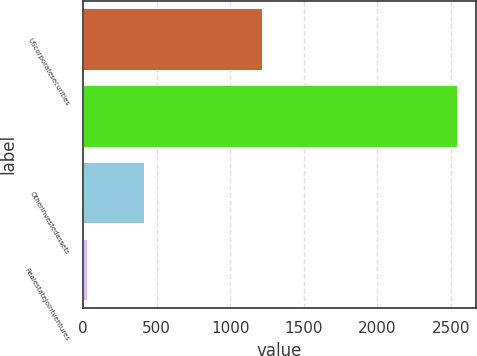Convert chart. <chart><loc_0><loc_0><loc_500><loc_500><bar_chart><fcel>UScorporatesecurities<fcel>Unnamed: 1<fcel>Otherinvestedassets<fcel>Realestatejointventures<nl><fcel>1216<fcel>2543<fcel>416<fcel>30<nl></chart> 